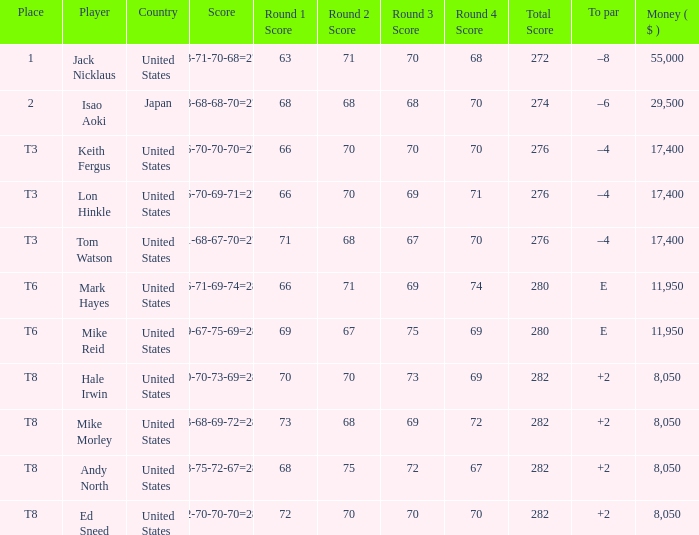What to par is located in the united states and has the player by the name of hale irwin? 2.0. 